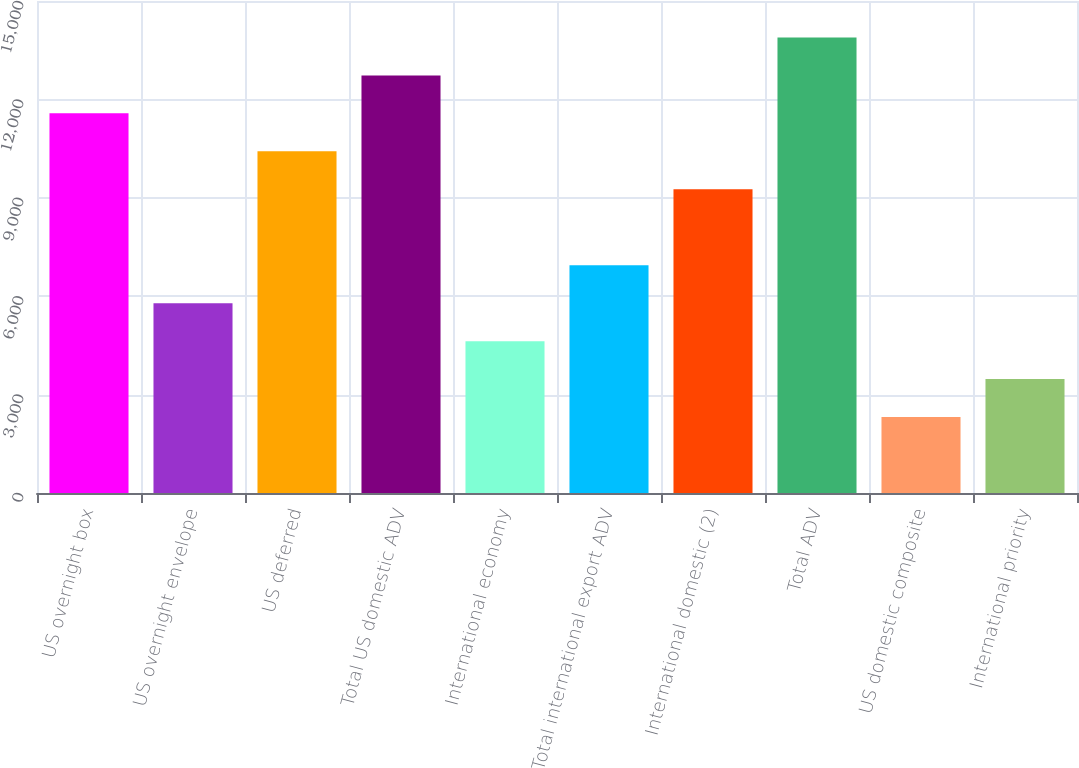Convert chart. <chart><loc_0><loc_0><loc_500><loc_500><bar_chart><fcel>US overnight box<fcel>US overnight envelope<fcel>US deferred<fcel>Total US domestic ADV<fcel>International economy<fcel>Total international export ADV<fcel>International domestic (2)<fcel>Total ADV<fcel>US domestic composite<fcel>International priority<nl><fcel>11574<fcel>5787.58<fcel>10416.7<fcel>12731.3<fcel>4630.3<fcel>6944.86<fcel>9259.42<fcel>13888.5<fcel>2315.74<fcel>3473.02<nl></chart> 